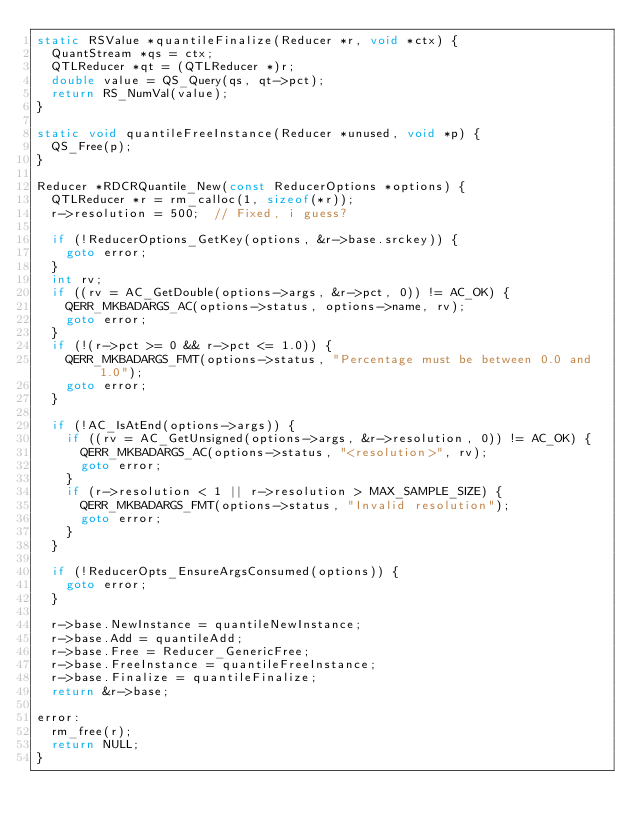Convert code to text. <code><loc_0><loc_0><loc_500><loc_500><_C_>static RSValue *quantileFinalize(Reducer *r, void *ctx) {
  QuantStream *qs = ctx;
  QTLReducer *qt = (QTLReducer *)r;
  double value = QS_Query(qs, qt->pct);
  return RS_NumVal(value);
}

static void quantileFreeInstance(Reducer *unused, void *p) {
  QS_Free(p);
}

Reducer *RDCRQuantile_New(const ReducerOptions *options) {
  QTLReducer *r = rm_calloc(1, sizeof(*r));
  r->resolution = 500;  // Fixed, i guess?

  if (!ReducerOptions_GetKey(options, &r->base.srckey)) {
    goto error;
  }
  int rv;
  if ((rv = AC_GetDouble(options->args, &r->pct, 0)) != AC_OK) {
    QERR_MKBADARGS_AC(options->status, options->name, rv);
    goto error;
  }
  if (!(r->pct >= 0 && r->pct <= 1.0)) {
    QERR_MKBADARGS_FMT(options->status, "Percentage must be between 0.0 and 1.0");
    goto error;
  }

  if (!AC_IsAtEnd(options->args)) {
    if ((rv = AC_GetUnsigned(options->args, &r->resolution, 0)) != AC_OK) {
      QERR_MKBADARGS_AC(options->status, "<resolution>", rv);
      goto error;
    }
    if (r->resolution < 1 || r->resolution > MAX_SAMPLE_SIZE) {
      QERR_MKBADARGS_FMT(options->status, "Invalid resolution");
      goto error;
    }
  }

  if (!ReducerOpts_EnsureArgsConsumed(options)) {
    goto error;
  }

  r->base.NewInstance = quantileNewInstance;
  r->base.Add = quantileAdd;
  r->base.Free = Reducer_GenericFree;
  r->base.FreeInstance = quantileFreeInstance;
  r->base.Finalize = quantileFinalize;
  return &r->base;

error:
  rm_free(r);
  return NULL;
}
</code> 